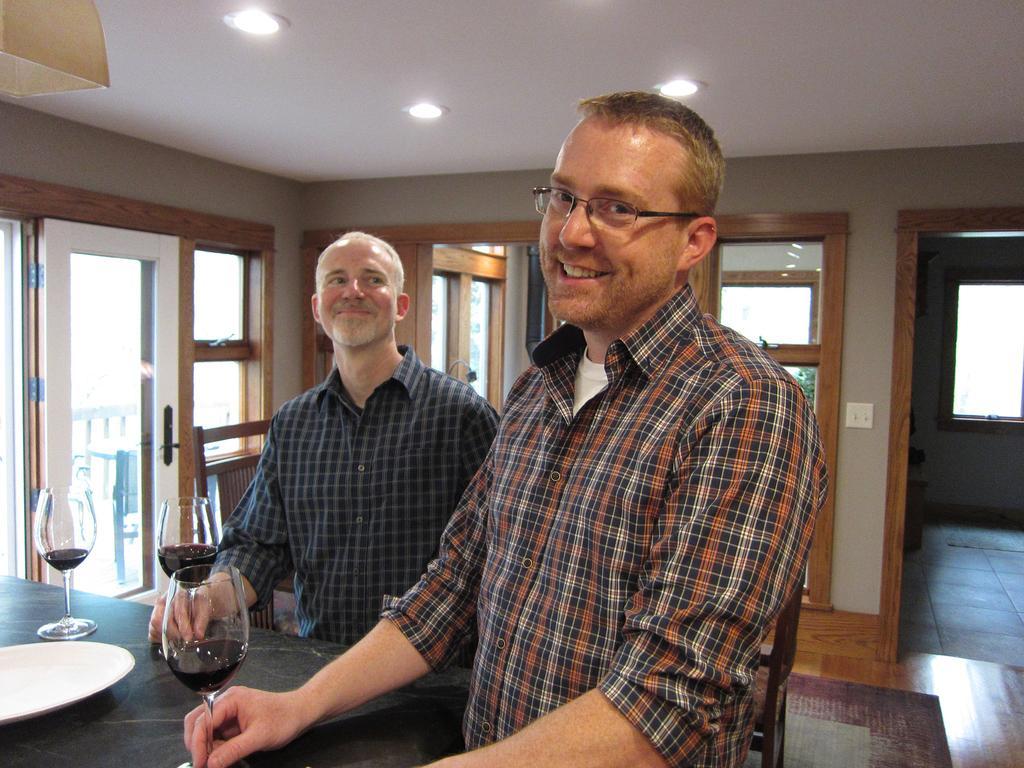Can you describe this image briefly? In this image I can see two people are standing and smiling. In front of them there is a plate and the wine glass. At the background there is a wall with window and lights. 